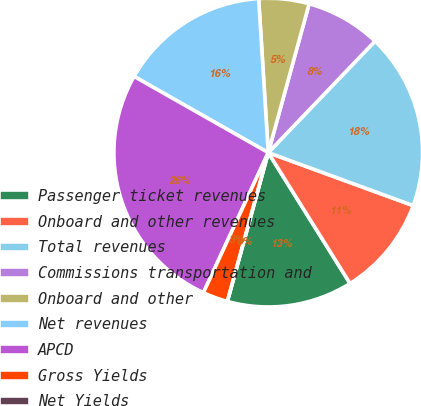Convert chart. <chart><loc_0><loc_0><loc_500><loc_500><pie_chart><fcel>Passenger ticket revenues<fcel>Onboard and other revenues<fcel>Total revenues<fcel>Commissions transportation and<fcel>Onboard and other<fcel>Net revenues<fcel>APCD<fcel>Gross Yields<fcel>Net Yields<nl><fcel>13.16%<fcel>10.53%<fcel>18.42%<fcel>7.89%<fcel>5.26%<fcel>15.79%<fcel>26.32%<fcel>2.63%<fcel>0.0%<nl></chart> 